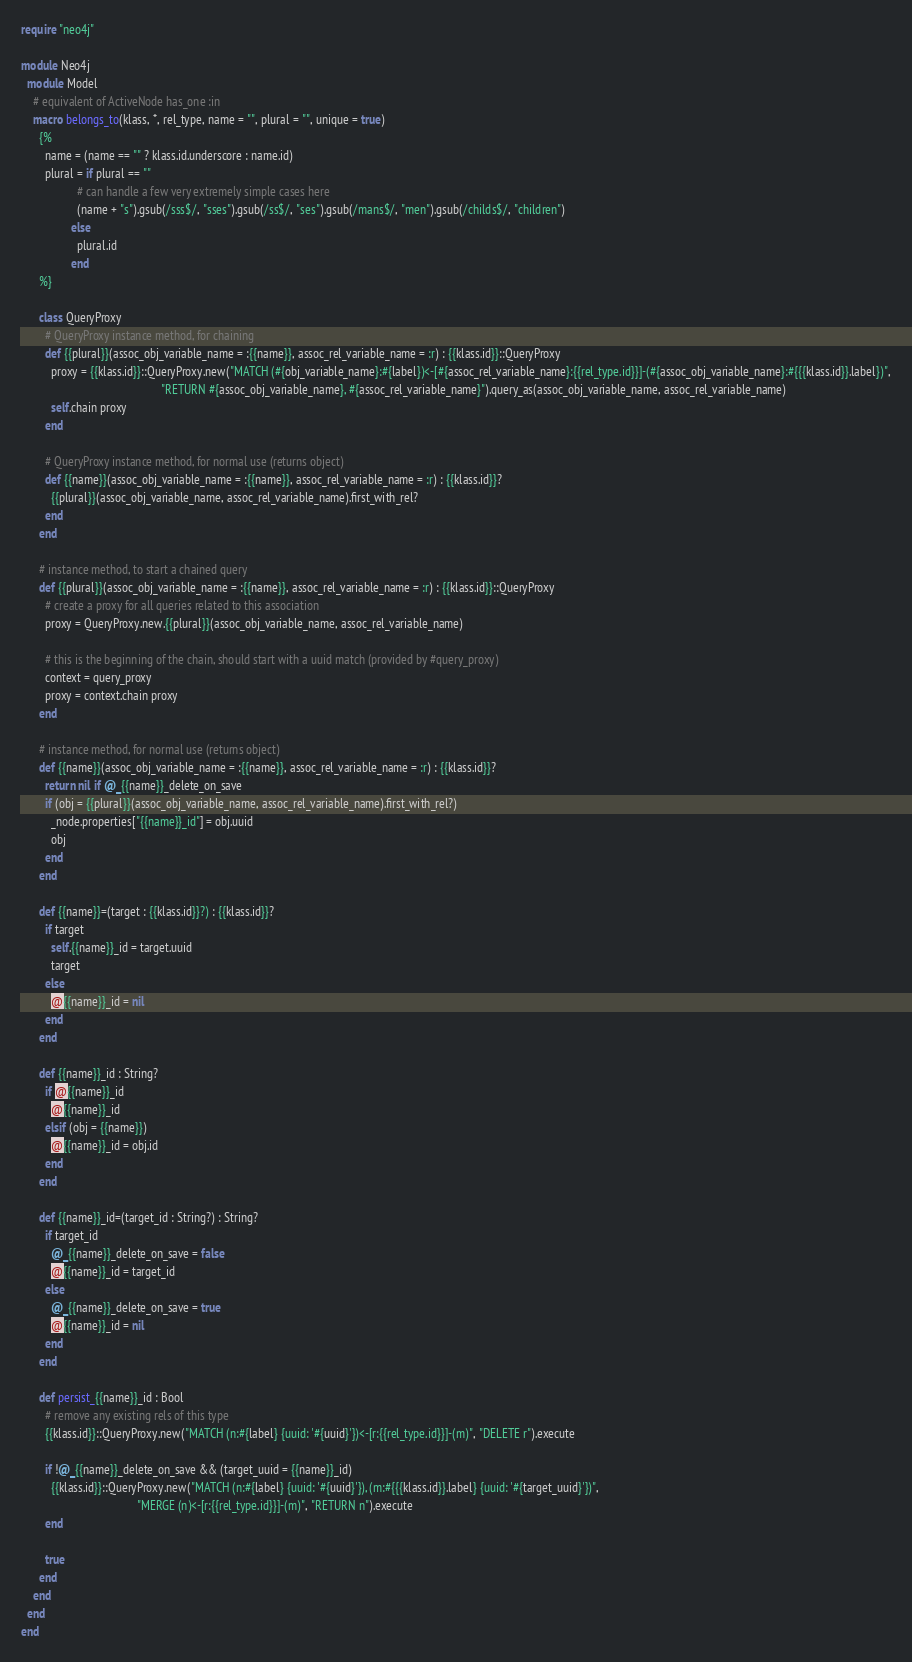Convert code to text. <code><loc_0><loc_0><loc_500><loc_500><_Crystal_>require "neo4j"

module Neo4j
  module Model
    # equivalent of ActiveNode has_one :in
    macro belongs_to(klass, *, rel_type, name = "", plural = "", unique = true)
      {%
        name = (name == "" ? klass.id.underscore : name.id)
        plural = if plural == ""
                   # can handle a few very extremely simple cases here
                   (name + "s").gsub(/sss$/, "sses").gsub(/ss$/, "ses").gsub(/mans$/, "men").gsub(/childs$/, "children")
                 else
                   plural.id
                 end
      %}

      class QueryProxy
        # QueryProxy instance method, for chaining
        def {{plural}}(assoc_obj_variable_name = :{{name}}, assoc_rel_variable_name = :r) : {{klass.id}}::QueryProxy
          proxy = {{klass.id}}::QueryProxy.new("MATCH (#{obj_variable_name}:#{label})<-[#{assoc_rel_variable_name}:{{rel_type.id}}]-(#{assoc_obj_variable_name}:#{{{klass.id}}.label})",
                                               "RETURN #{assoc_obj_variable_name}, #{assoc_rel_variable_name}").query_as(assoc_obj_variable_name, assoc_rel_variable_name)
          self.chain proxy
        end

        # QueryProxy instance method, for normal use (returns object)
        def {{name}}(assoc_obj_variable_name = :{{name}}, assoc_rel_variable_name = :r) : {{klass.id}}?
          {{plural}}(assoc_obj_variable_name, assoc_rel_variable_name).first_with_rel?
        end
      end

      # instance method, to start a chained query
      def {{plural}}(assoc_obj_variable_name = :{{name}}, assoc_rel_variable_name = :r) : {{klass.id}}::QueryProxy
        # create a proxy for all queries related to this association
        proxy = QueryProxy.new.{{plural}}(assoc_obj_variable_name, assoc_rel_variable_name)

        # this is the beginning of the chain, should start with a uuid match (provided by #query_proxy)
        context = query_proxy
        proxy = context.chain proxy
      end

      # instance method, for normal use (returns object)
      def {{name}}(assoc_obj_variable_name = :{{name}}, assoc_rel_variable_name = :r) : {{klass.id}}?
        return nil if @_{{name}}_delete_on_save
        if (obj = {{plural}}(assoc_obj_variable_name, assoc_rel_variable_name).first_with_rel?)
          _node.properties["{{name}}_id"] = obj.uuid
          obj
        end
      end

      def {{name}}=(target : {{klass.id}}?) : {{klass.id}}?
        if target
          self.{{name}}_id = target.uuid
          target
        else
          @{{name}}_id = nil
        end
      end

      def {{name}}_id : String?
        if @{{name}}_id
          @{{name}}_id
        elsif (obj = {{name}})
          @{{name}}_id = obj.id
        end
      end

      def {{name}}_id=(target_id : String?) : String?
        if target_id
          @_{{name}}_delete_on_save = false
          @{{name}}_id = target_id
        else
          @_{{name}}_delete_on_save = true
          @{{name}}_id = nil
        end
      end

      def persist_{{name}}_id : Bool
        # remove any existing rels of this type
        {{klass.id}}::QueryProxy.new("MATCH (n:#{label} {uuid: '#{uuid}'})<-[r:{{rel_type.id}}]-(m)", "DELETE r").execute

        if !@_{{name}}_delete_on_save && (target_uuid = {{name}}_id)
          {{klass.id}}::QueryProxy.new("MATCH (n:#{label} {uuid: '#{uuid}'}), (m:#{{{klass.id}}.label} {uuid: '#{target_uuid}'})",
                                       "MERGE (n)<-[r:{{rel_type.id}}]-(m)", "RETURN n").execute
        end

        true
      end
    end
  end
end
</code> 